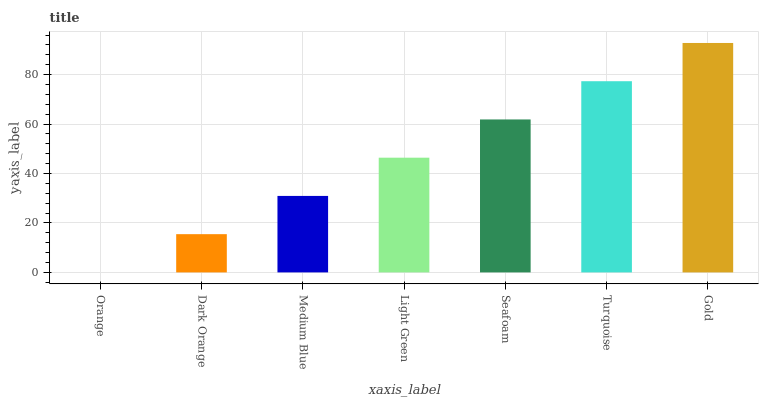Is Orange the minimum?
Answer yes or no. Yes. Is Gold the maximum?
Answer yes or no. Yes. Is Dark Orange the minimum?
Answer yes or no. No. Is Dark Orange the maximum?
Answer yes or no. No. Is Dark Orange greater than Orange?
Answer yes or no. Yes. Is Orange less than Dark Orange?
Answer yes or no. Yes. Is Orange greater than Dark Orange?
Answer yes or no. No. Is Dark Orange less than Orange?
Answer yes or no. No. Is Light Green the high median?
Answer yes or no. Yes. Is Light Green the low median?
Answer yes or no. Yes. Is Dark Orange the high median?
Answer yes or no. No. Is Orange the low median?
Answer yes or no. No. 